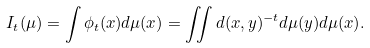<formula> <loc_0><loc_0><loc_500><loc_500>I _ { t } ( \mu ) = \int \phi _ { t } ( x ) d \mu ( x ) = \iint d ( x , y ) ^ { - t } d \mu ( y ) d \mu ( x ) .</formula> 